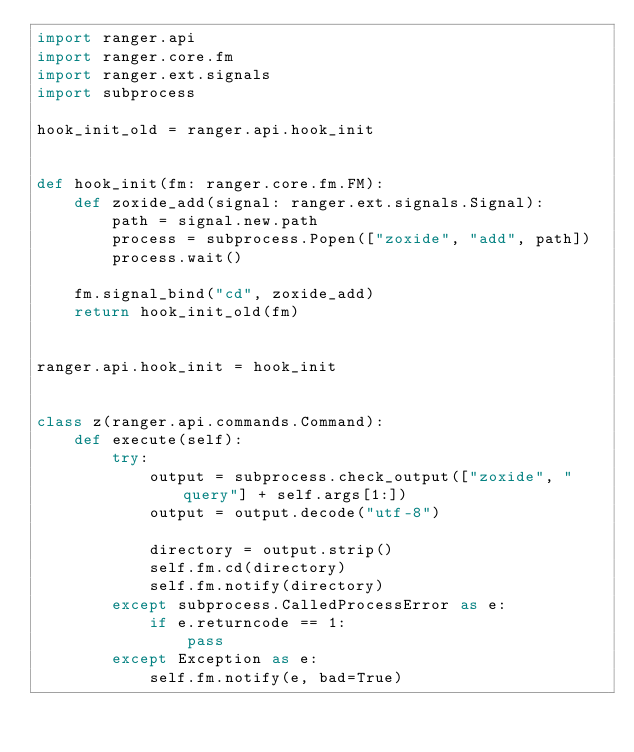<code> <loc_0><loc_0><loc_500><loc_500><_Python_>import ranger.api
import ranger.core.fm
import ranger.ext.signals
import subprocess

hook_init_old = ranger.api.hook_init


def hook_init(fm: ranger.core.fm.FM):
    def zoxide_add(signal: ranger.ext.signals.Signal):
        path = signal.new.path
        process = subprocess.Popen(["zoxide", "add", path])
        process.wait()

    fm.signal_bind("cd", zoxide_add)
    return hook_init_old(fm)


ranger.api.hook_init = hook_init


class z(ranger.api.commands.Command):
    def execute(self):
        try:
            output = subprocess.check_output(["zoxide", "query"] + self.args[1:])
            output = output.decode("utf-8")

            directory = output.strip()
            self.fm.cd(directory)
            self.fm.notify(directory)
        except subprocess.CalledProcessError as e:
            if e.returncode == 1:
                pass
        except Exception as e:
            self.fm.notify(e, bad=True)

</code> 